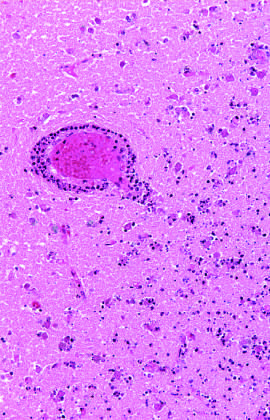s the vascular supply intact?
Answer the question using a single word or phrase. Yes 